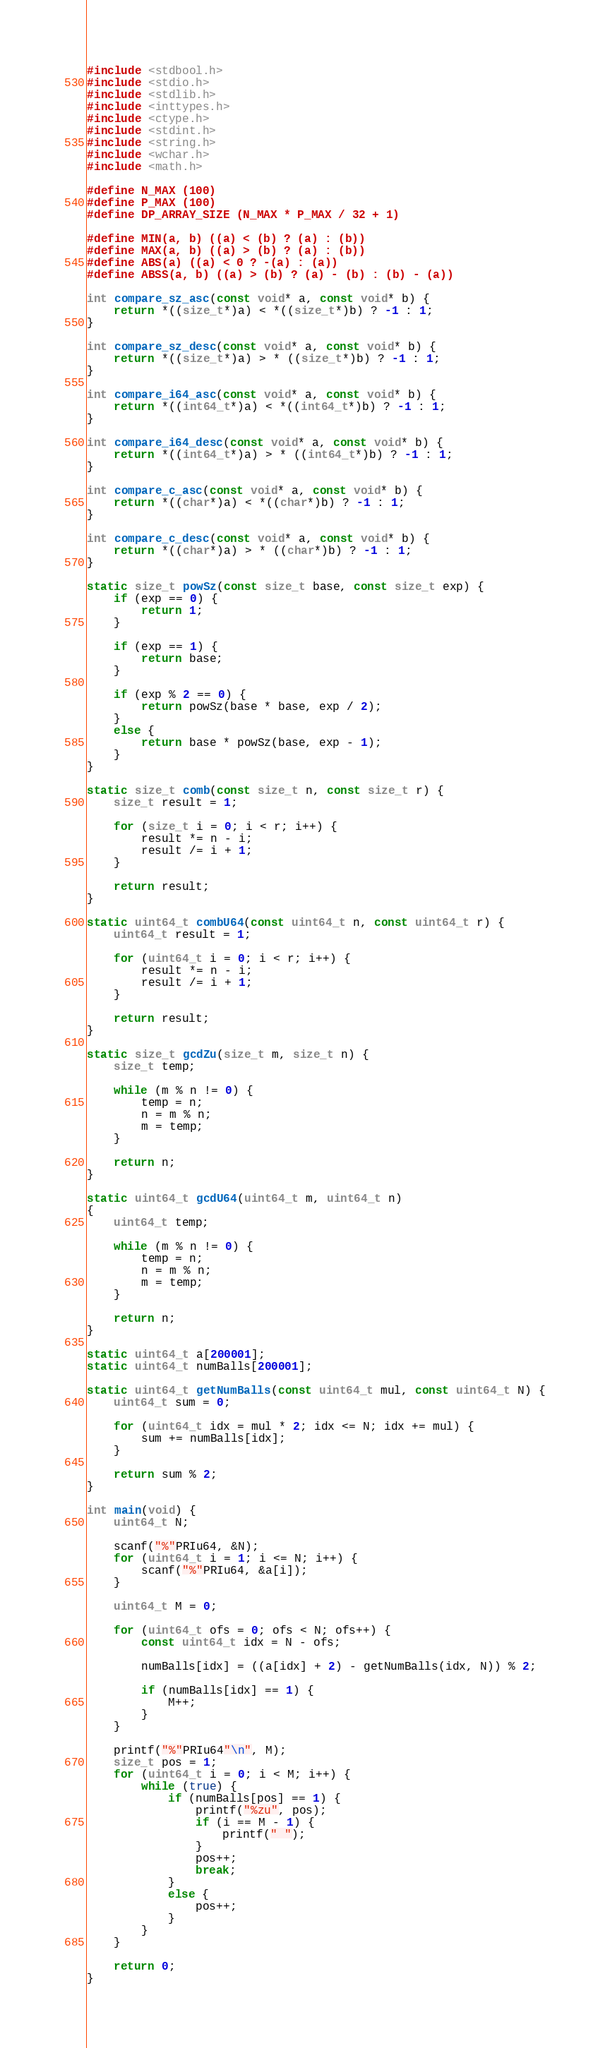<code> <loc_0><loc_0><loc_500><loc_500><_C_>#include <stdbool.h>
#include <stdio.h>
#include <stdlib.h>
#include <inttypes.h>
#include <ctype.h>
#include <stdint.h>
#include <string.h>
#include <wchar.h>
#include <math.h>

#define N_MAX (100)
#define P_MAX (100)
#define DP_ARRAY_SIZE (N_MAX * P_MAX / 32 + 1)

#define MIN(a, b) ((a) < (b) ? (a) : (b))
#define MAX(a, b) ((a) > (b) ? (a) : (b))
#define ABS(a) ((a) < 0 ? -(a) : (a))
#define ABSS(a, b) ((a) > (b) ? (a) - (b) : (b) - (a))

int compare_sz_asc(const void* a, const void* b) {
    return *((size_t*)a) < *((size_t*)b) ? -1 : 1;
}

int compare_sz_desc(const void* a, const void* b) {
    return *((size_t*)a) > * ((size_t*)b) ? -1 : 1;
}

int compare_i64_asc(const void* a, const void* b) {
    return *((int64_t*)a) < *((int64_t*)b) ? -1 : 1;
}

int compare_i64_desc(const void* a, const void* b) {
    return *((int64_t*)a) > * ((int64_t*)b) ? -1 : 1;
}

int compare_c_asc(const void* a, const void* b) {
    return *((char*)a) < *((char*)b) ? -1 : 1;
}

int compare_c_desc(const void* a, const void* b) {
    return *((char*)a) > * ((char*)b) ? -1 : 1;
}

static size_t powSz(const size_t base, const size_t exp) {
    if (exp == 0) {
        return 1;
    }

    if (exp == 1) {
        return base;
    }

    if (exp % 2 == 0) {
        return powSz(base * base, exp / 2);
    }
    else {
        return base * powSz(base, exp - 1);
    }
}

static size_t comb(const size_t n, const size_t r) {
    size_t result = 1;

    for (size_t i = 0; i < r; i++) {
        result *= n - i;
        result /= i + 1;
    }

    return result;
}

static uint64_t combU64(const uint64_t n, const uint64_t r) {
    uint64_t result = 1;

    for (uint64_t i = 0; i < r; i++) {
        result *= n - i;
        result /= i + 1;
    }

    return result;
}

static size_t gcdZu(size_t m, size_t n) {
    size_t temp;

    while (m % n != 0) {
        temp = n;
        n = m % n;
        m = temp;
    }

    return n;
}

static uint64_t gcdU64(uint64_t m, uint64_t n)
{
    uint64_t temp;

    while (m % n != 0) {
        temp = n;
        n = m % n;
        m = temp;
    }

    return n;
}

static uint64_t a[200001];
static uint64_t numBalls[200001];

static uint64_t getNumBalls(const uint64_t mul, const uint64_t N) {
    uint64_t sum = 0;

    for (uint64_t idx = mul * 2; idx <= N; idx += mul) {
        sum += numBalls[idx];
    }

    return sum % 2;
}

int main(void) {
    uint64_t N;

    scanf("%"PRIu64, &N);
    for (uint64_t i = 1; i <= N; i++) {
        scanf("%"PRIu64, &a[i]);
    }

    uint64_t M = 0;

    for (uint64_t ofs = 0; ofs < N; ofs++) {
        const uint64_t idx = N - ofs;

        numBalls[idx] = ((a[idx] + 2) - getNumBalls(idx, N)) % 2;

        if (numBalls[idx] == 1) {
            M++;
        }
    }

    printf("%"PRIu64"\n", M);
    size_t pos = 1;
    for (uint64_t i = 0; i < M; i++) {
        while (true) {
            if (numBalls[pos] == 1) {
                printf("%zu", pos);
                if (i == M - 1) {
                    printf(" ");
                }
                pos++;
                break;
            }
            else {
                pos++;
            }
        }
    }

    return 0;
}
</code> 